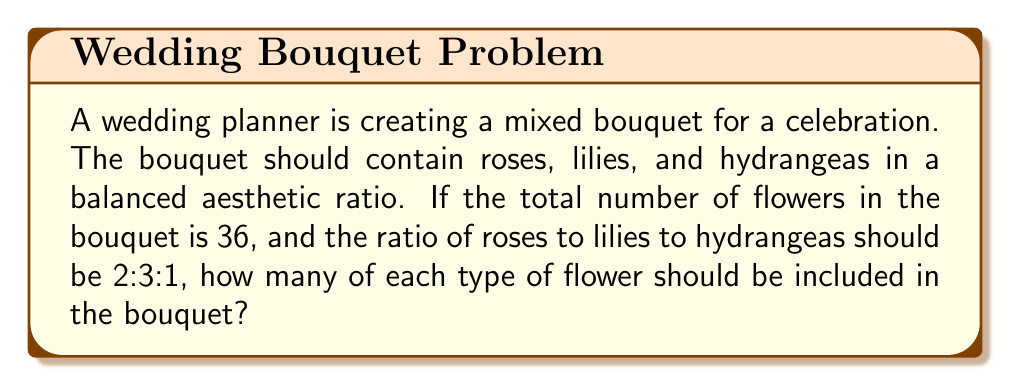Provide a solution to this math problem. To solve this problem, we'll use the concept of ratios and proportions.

1. Let's define variables:
   $r$ = number of roses
   $l$ = number of lilies
   $h$ = number of hydrangeas

2. Given information:
   Total flowers: $r + l + h = 36$
   Ratio of roses : lilies : hydrangeas = 2 : 3 : 1

3. Let's express each flower count in terms of a single variable, $x$:
   $r = 2x$
   $l = 3x$
   $h = x$

4. Substitute these into the total flowers equation:
   $2x + 3x + x = 36$
   $6x = 36$

5. Solve for $x$:
   $x = 36 \div 6 = 6$

6. Now we can calculate the number of each flower:
   Roses: $r = 2x = 2(6) = 12$
   Lilies: $l = 3x = 3(6) = 18$
   Hydrangeas: $h = x = 6$

7. Verify the total:
   $12 + 18 + 6 = 36$

Therefore, the bouquet should contain 12 roses, 18 lilies, and 6 hydrangeas to maintain the desired ratio and total flower count.
Answer: The bouquet should contain 12 roses, 18 lilies, and 6 hydrangeas. 